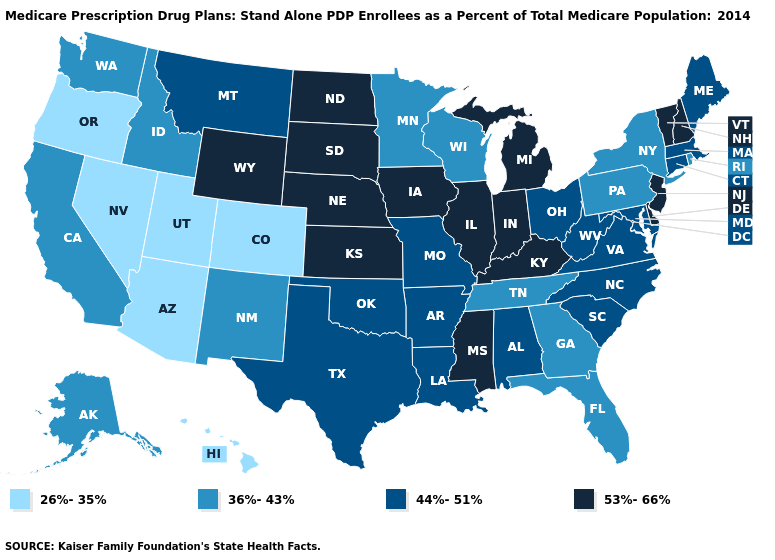Does the first symbol in the legend represent the smallest category?
Concise answer only. Yes. Does Arkansas have a higher value than Alaska?
Keep it brief. Yes. What is the highest value in the MidWest ?
Answer briefly. 53%-66%. Name the states that have a value in the range 26%-35%?
Be succinct. Arizona, Colorado, Hawaii, Nevada, Oregon, Utah. Name the states that have a value in the range 26%-35%?
Give a very brief answer. Arizona, Colorado, Hawaii, Nevada, Oregon, Utah. Among the states that border North Dakota , which have the highest value?
Answer briefly. South Dakota. How many symbols are there in the legend?
Give a very brief answer. 4. What is the value of Oklahoma?
Give a very brief answer. 44%-51%. Name the states that have a value in the range 36%-43%?
Quick response, please. Alaska, California, Florida, Georgia, Idaho, Minnesota, New Mexico, New York, Pennsylvania, Rhode Island, Tennessee, Washington, Wisconsin. What is the lowest value in the MidWest?
Give a very brief answer. 36%-43%. How many symbols are there in the legend?
Give a very brief answer. 4. How many symbols are there in the legend?
Short answer required. 4. Does Wyoming have the same value as Kansas?
Quick response, please. Yes. Among the states that border Missouri , which have the highest value?
Concise answer only. Iowa, Illinois, Kansas, Kentucky, Nebraska. Does New Jersey have the highest value in the USA?
Quick response, please. Yes. 